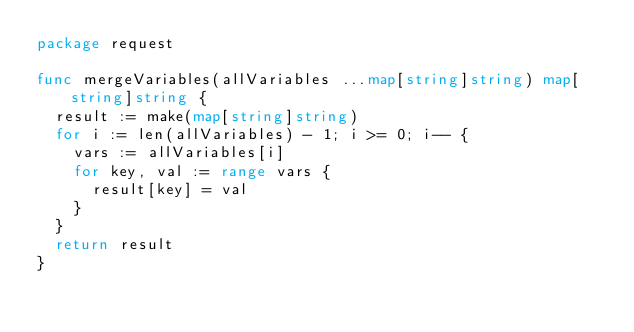<code> <loc_0><loc_0><loc_500><loc_500><_Go_>package request

func mergeVariables(allVariables ...map[string]string) map[string]string {
	result := make(map[string]string)
	for i := len(allVariables) - 1; i >= 0; i-- {
		vars := allVariables[i]
		for key, val := range vars {
			result[key] = val
		}
	}
	return result
}
</code> 